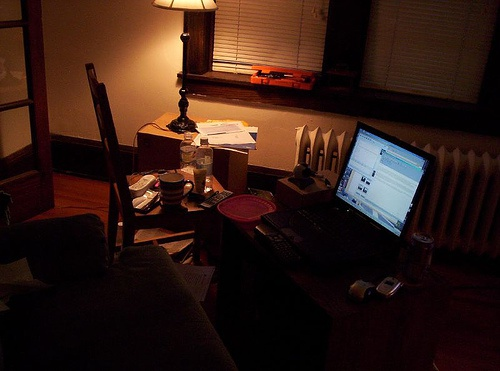Describe the objects in this image and their specific colors. I can see couch in black and maroon tones, laptop in maroon, black, lightblue, and gray tones, chair in maroon, black, brown, and tan tones, keyboard in black, gray, and maroon tones, and book in maroon, tan, and brown tones in this image. 